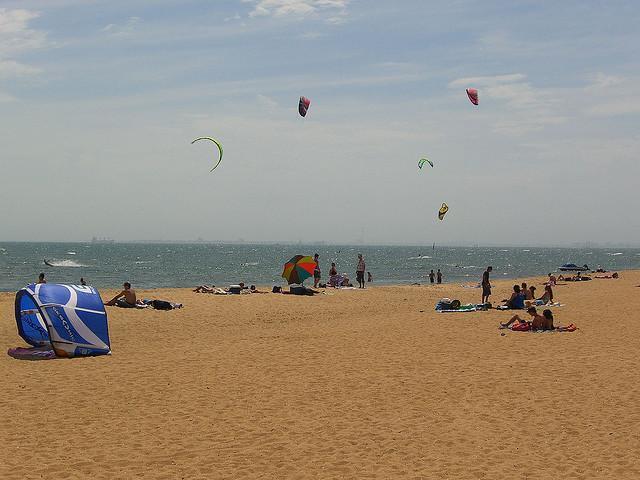How many umbrellas are visible?
Give a very brief answer. 1. How many kites are flying?
Give a very brief answer. 5. How many chairs are visible?
Give a very brief answer. 0. 